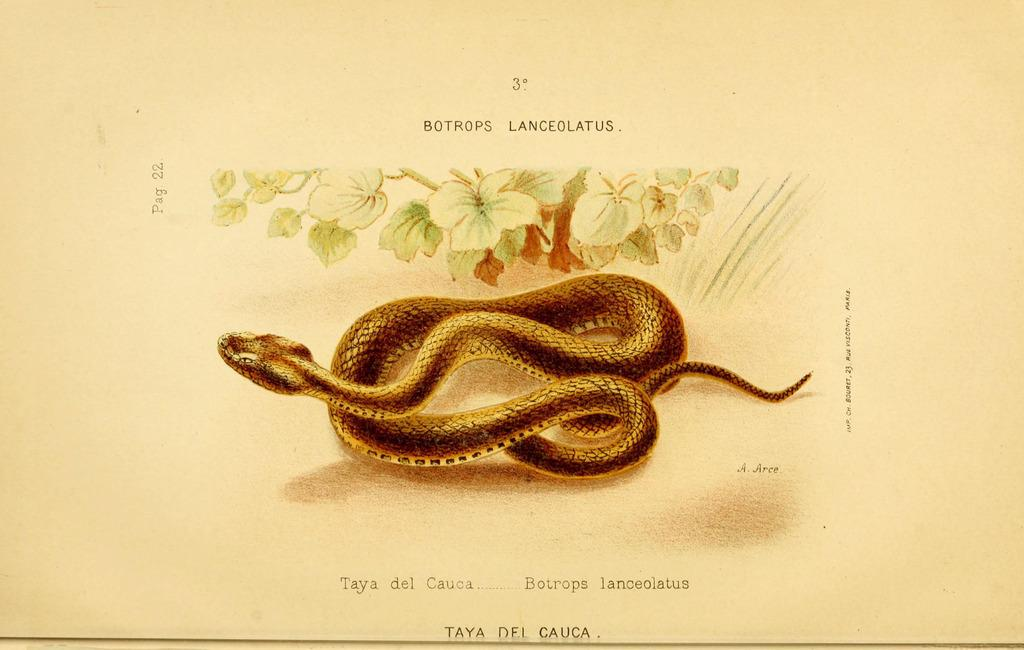What is depicted in the image? There is a picture of a snake and a picture of a plant in the image. What is the medium for these pictures? The pictures are on a paper. Are there any additional elements on the paper? Yes, there are texts written on the paper. How many ants can be seen crawling on the snake in the image? There are no ants present in the image; it only features a picture of a snake and a picture of a plant on a paper with texts. 